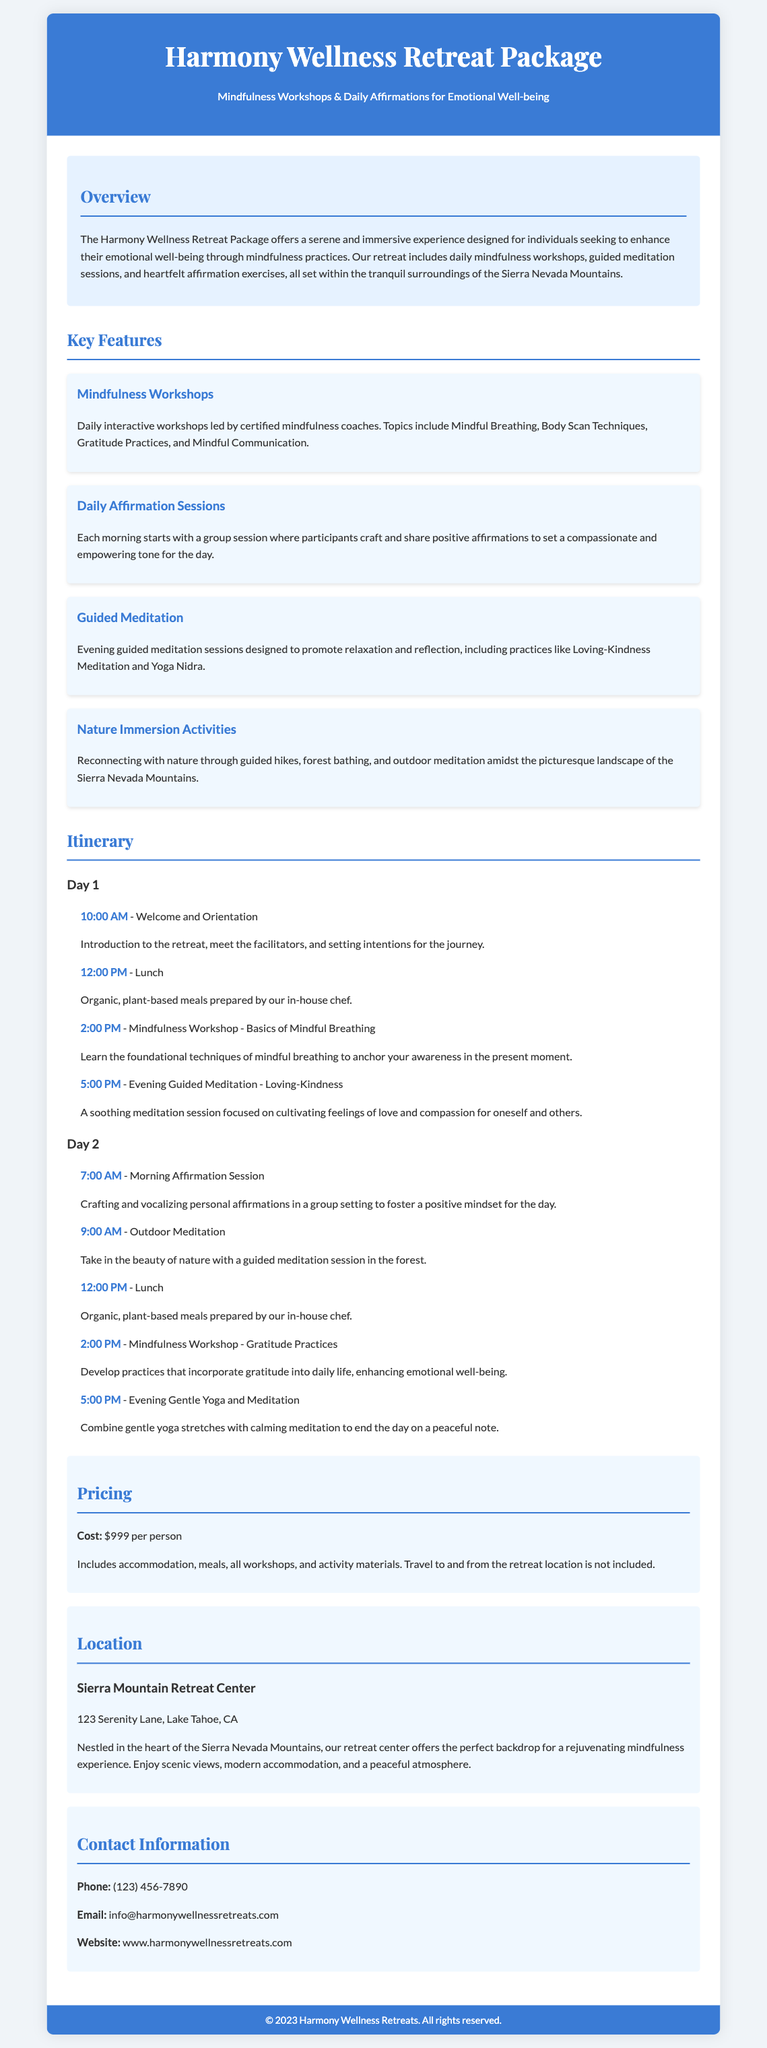What is the name of the retreat package? The retreat package is called "Harmony Wellness Retreat Package."
Answer: Harmony Wellness Retreat Package What is the location of the retreat? The location of the retreat is Sierra Mountain Retreat Center, 123 Serenity Lane, Lake Tahoe, CA.
Answer: Sierra Mountain Retreat Center What is the cost per person for the retreat? The cost per person for the retreat is specified in the pricing section.
Answer: $999 What types of daily activities are included in the retreat? The daily activities include mindfulness workshops, affirmation sessions, guided meditation, and nature immersion activities.
Answer: Mindfulness workshops, daily affirmation sessions, guided meditation, nature immersion activities How many days does the itinerary cover? The itinerary provided covers activities for two days with individual schedules listed.
Answer: Two days What type of food is provided at the retreat? The type of food provided at the retreat is organic and plant-based meals prepared by an in-house chef.
Answer: Organic, plant-based meals What is included in the cost of the retreat? The cost includes accommodation, meals, all workshops, and activity materials, as stated under pricing.
Answer: Accommodation, meals, workshops, activity materials What is the focus of the mindfulness workshops? The focus of the mindfulness workshops includes various practices like Mindful Breathing, Body Scan Techniques, Gratitude Practices, and Mindful Communication.
Answer: Mindful Breathing, Body Scan Techniques, Gratitude Practices, Mindful Communication What is the goal of the morning affirmation sessions? The goal of the morning affirmation sessions is to craft and share positive affirmations to foster a compassionate and empowering tone for the day.
Answer: Craft and share positive affirmations 